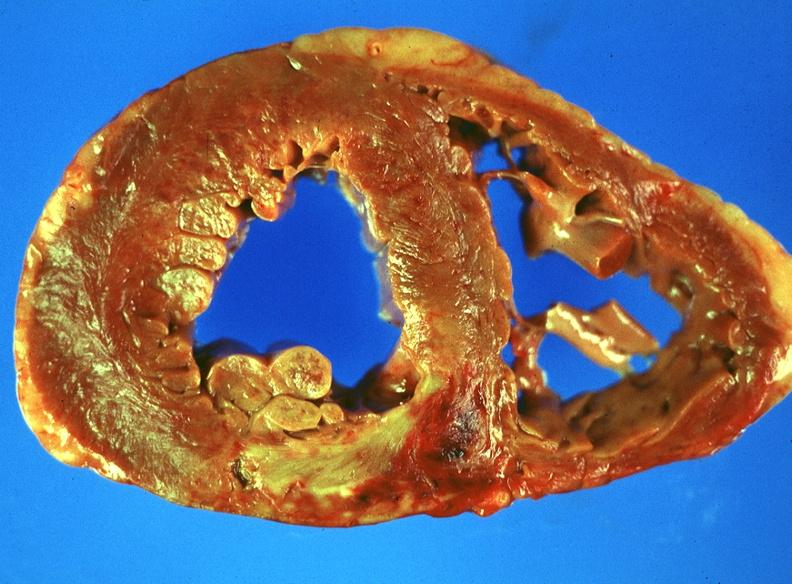where is this?
Answer the question using a single word or phrase. Heart 